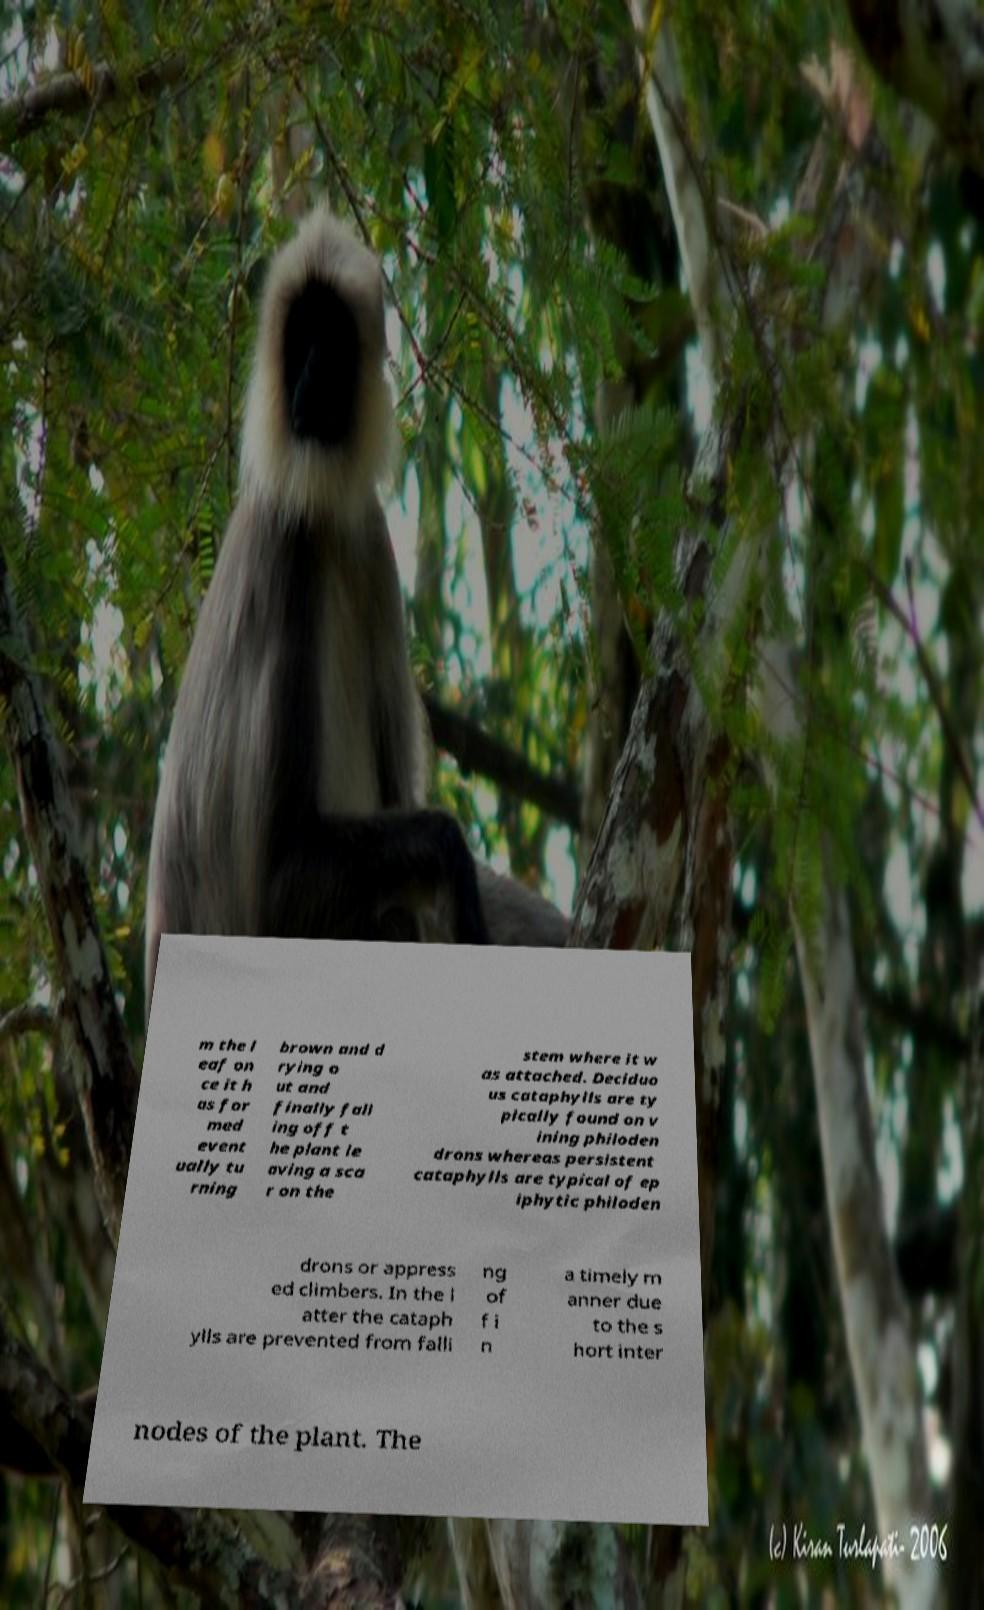Please read and relay the text visible in this image. What does it say? m the l eaf on ce it h as for med event ually tu rning brown and d rying o ut and finally fall ing off t he plant le aving a sca r on the stem where it w as attached. Deciduo us cataphylls are ty pically found on v ining philoden drons whereas persistent cataphylls are typical of ep iphytic philoden drons or appress ed climbers. In the l atter the cataph ylls are prevented from falli ng of f i n a timely m anner due to the s hort inter nodes of the plant. The 